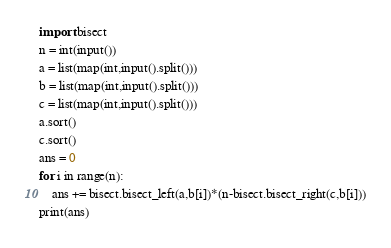Convert code to text. <code><loc_0><loc_0><loc_500><loc_500><_Python_>import bisect
n = int(input())
a = list(map(int,input().split()))
b = list(map(int,input().split()))
c = list(map(int,input().split()))
a.sort()
c.sort()
ans = 0
for i in range(n):
    ans += bisect.bisect_left(a,b[i])*(n-bisect.bisect_right(c,b[i]))
print(ans)</code> 